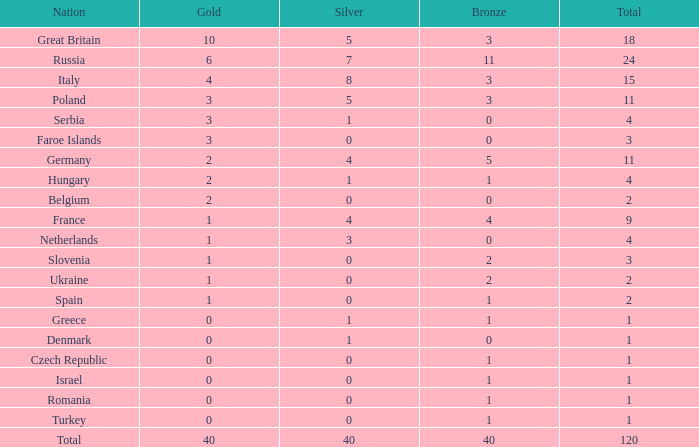What Nation has a Gold entry that is greater than 0, a Total that is greater than 2, a Silver entry that is larger than 1, and 0 Bronze? Netherlands. 